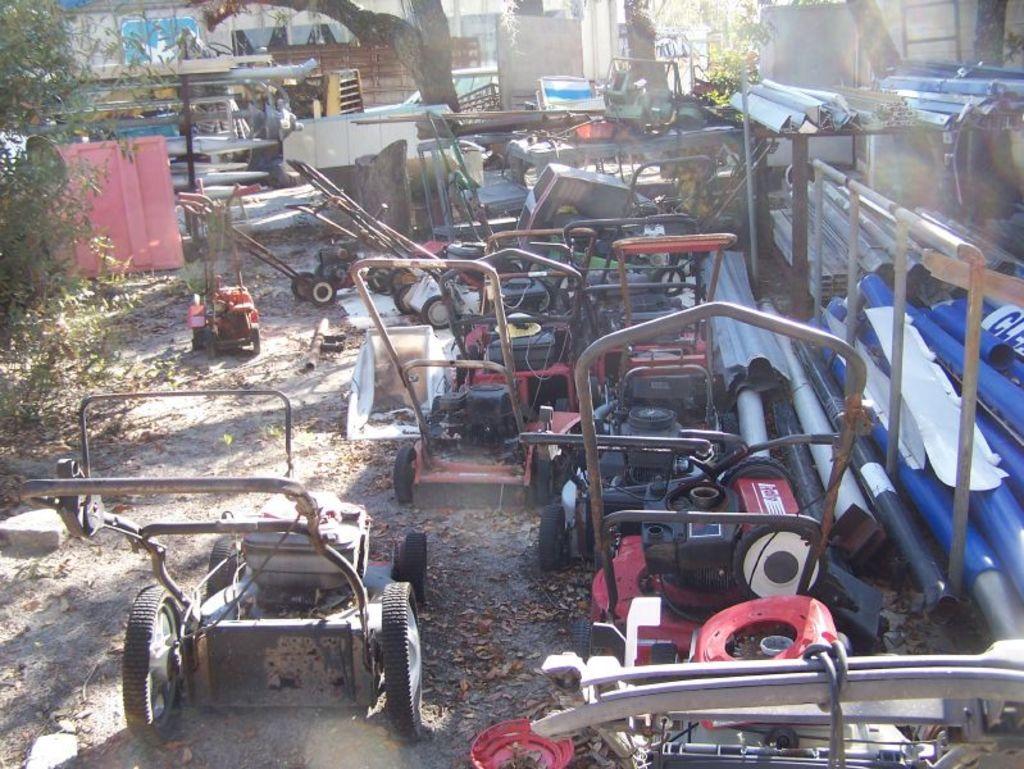In one or two sentences, can you explain what this image depicts? In the center of the image we can see trolley machines, pipes, rods, ladder, trees, shed are there. At the bottom of the image we can see dry leaves, ground, rocks are present. 